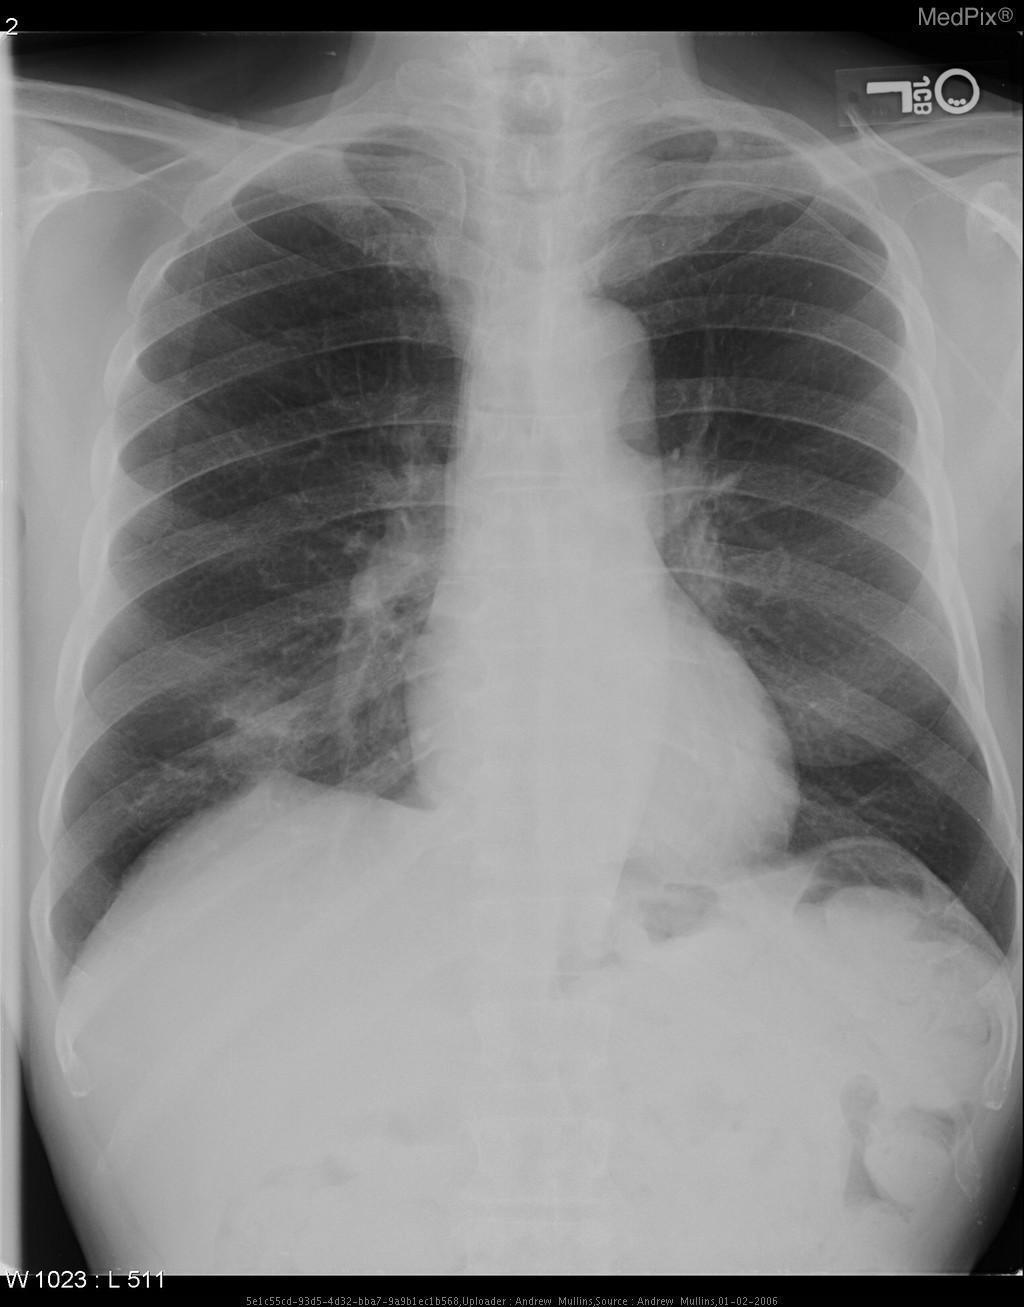What imaging modality is used?
Answer briefly. Xray. Is there any costophrenic angle blunting present?
Answer briefly. No. Is there presence of any costophrenic angle blunting?
Answer briefly. No. Any tracheal deviation present?
Write a very short answer. No. Is there any presence of tracheal deviation?
Short answer required. No. 